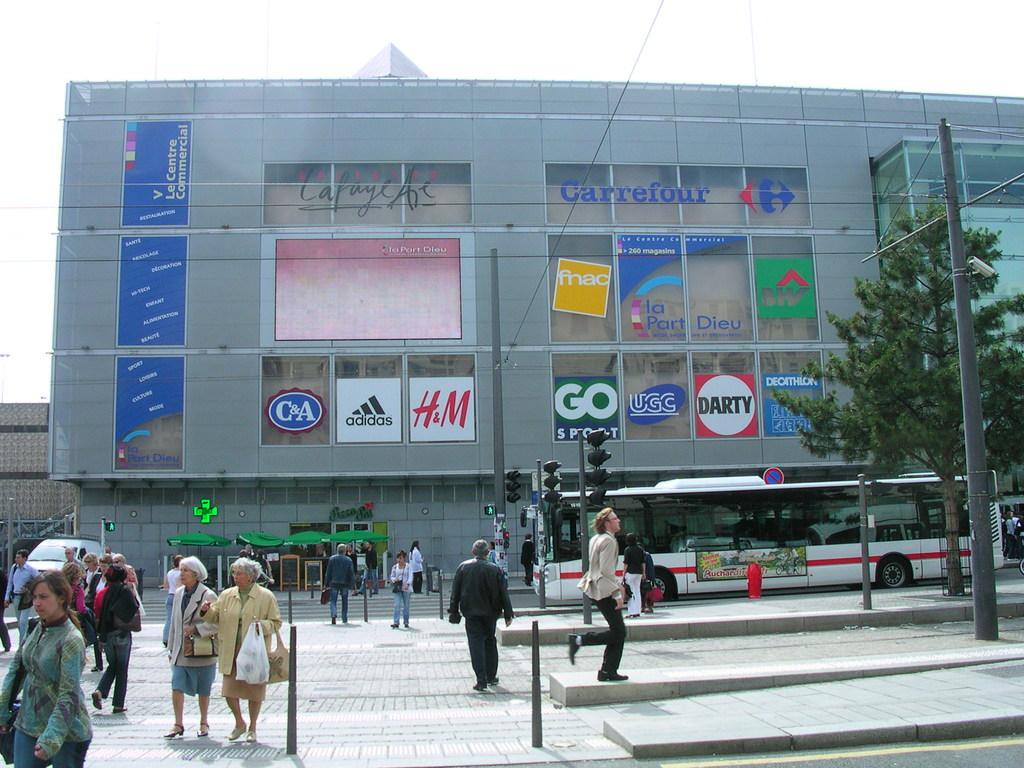What are the people in the image doing? The people in the image are standing on the ground. What are some of the people holding? Some of the people are holding objects. What can be seen in the background of the image? There is a building, a tree, vehicles, poles, and the sky visible in the background. What religion is being practiced by the people in the image? There is no indication of any religious practice in the image. What type of line is being drawn by the people in the image? There is no line being drawn by the people in the image. 